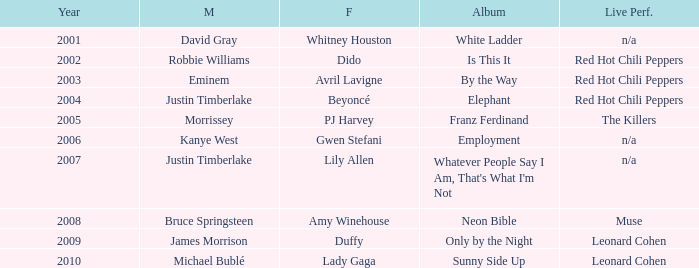Can you give me this table as a dict? {'header': ['Year', 'M', 'F', 'Album', 'Live Perf.'], 'rows': [['2001', 'David Gray', 'Whitney Houston', 'White Ladder', 'n/a'], ['2002', 'Robbie Williams', 'Dido', 'Is This It', 'Red Hot Chili Peppers'], ['2003', 'Eminem', 'Avril Lavigne', 'By the Way', 'Red Hot Chili Peppers'], ['2004', 'Justin Timberlake', 'Beyoncé', 'Elephant', 'Red Hot Chili Peppers'], ['2005', 'Morrissey', 'PJ Harvey', 'Franz Ferdinand', 'The Killers'], ['2006', 'Kanye West', 'Gwen Stefani', 'Employment', 'n/a'], ['2007', 'Justin Timberlake', 'Lily Allen', "Whatever People Say I Am, That's What I'm Not", 'n/a'], ['2008', 'Bruce Springsteen', 'Amy Winehouse', 'Neon Bible', 'Muse'], ['2009', 'James Morrison', 'Duffy', 'Only by the Night', 'Leonard Cohen'], ['2010', 'Michael Bublé', 'Lady Gaga', 'Sunny Side Up', 'Leonard Cohen']]} Which male is paired with dido in 2004? Robbie Williams. 